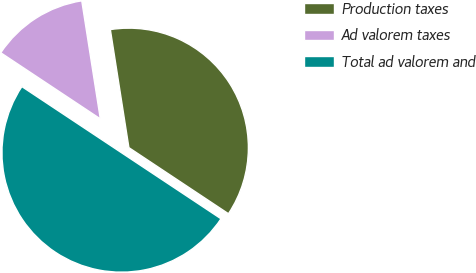Convert chart. <chart><loc_0><loc_0><loc_500><loc_500><pie_chart><fcel>Production taxes<fcel>Ad valorem taxes<fcel>Total ad valorem and<nl><fcel>36.81%<fcel>13.19%<fcel>50.0%<nl></chart> 